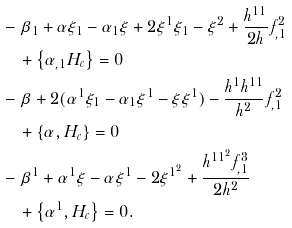Convert formula to latex. <formula><loc_0><loc_0><loc_500><loc_500>& - \beta _ { 1 } + \alpha \xi _ { 1 } - \alpha _ { 1 } \xi + 2 \xi ^ { 1 } \xi _ { 1 } - \xi ^ { 2 } + \frac { h ^ { 1 1 } } { 2 h } f _ { , 1 } ^ { 2 } \\ & \quad + \left \{ \alpha _ { , 1 } H _ { c } \right \} = 0 \\ & - \beta + 2 ( \alpha ^ { 1 } \xi _ { 1 } - \alpha _ { 1 } \xi ^ { 1 } - \xi \xi ^ { 1 } ) - \frac { h ^ { 1 } h ^ { 1 1 } } { h ^ { 2 } } f _ { , 1 } ^ { 2 } \\ & \quad + \left \{ \alpha , H _ { c } \right \} = 0 \\ & - \beta ^ { 1 } + \alpha ^ { 1 } \xi - \alpha \xi ^ { 1 } - 2 \xi ^ { 1 ^ { 2 } } + \frac { h ^ { 1 1 ^ { 2 } } f _ { , 1 } ^ { 3 } } { 2 h ^ { 2 } } \\ & \quad + \left \{ \alpha ^ { 1 } , H _ { c } \right \} = 0 .</formula> 